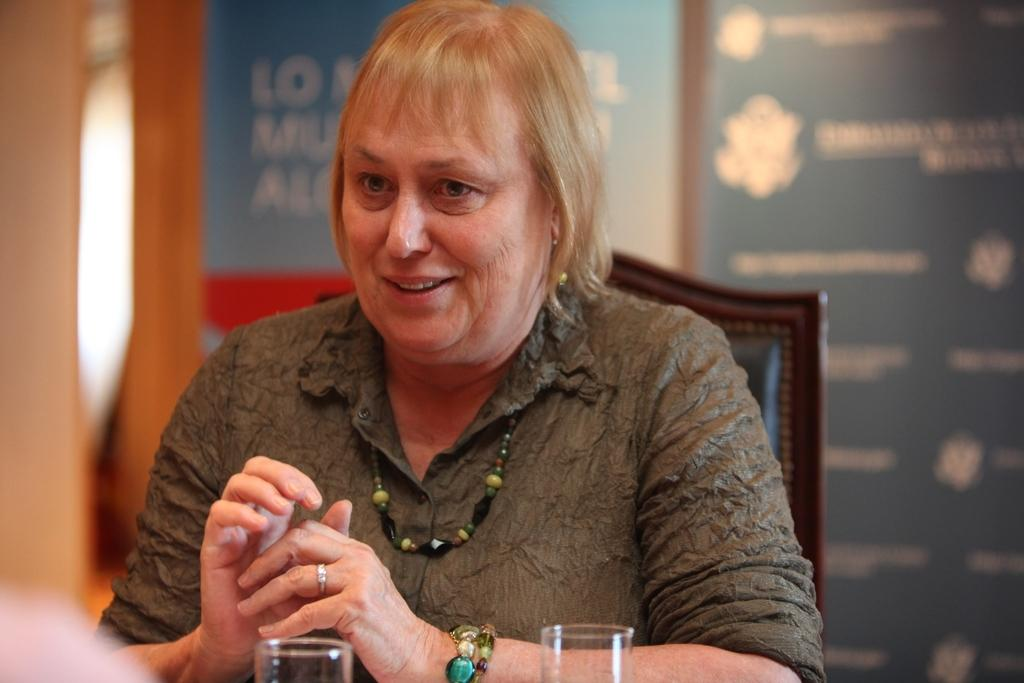What is the hair color of the woman in the image? The woman in the image has blond hair. What is the woman wearing on her upper body? The woman is wearing a grey shirt. What accessory is the woman wearing around her neck? The woman is wearing a necklace. What is the woman's posture in the image? The woman is sitting on a chair. What object is on the table in front of the woman? There is a glass on a table in front of the woman. What can be seen in the background of the image? There are advertisement boards in the background of the image. What type of monkey is sitting on the floor in the image? There is no monkey present in the image; it features a blond-haired woman sitting on a chair. 